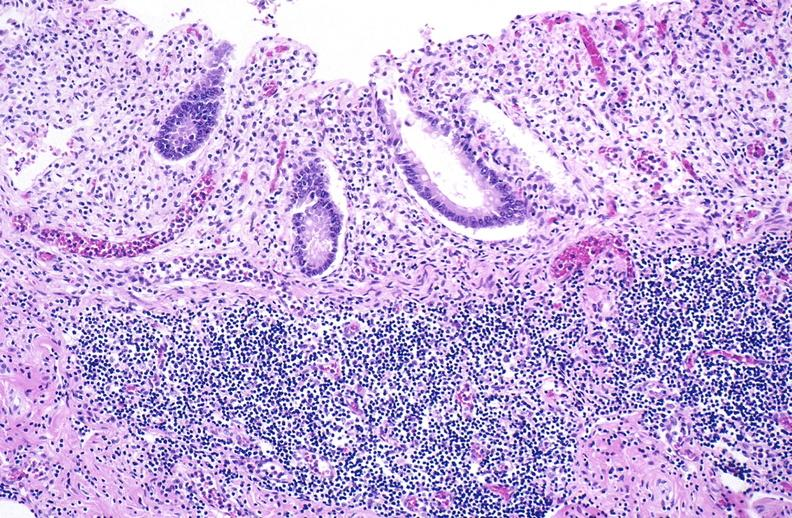s an opened peritoneal cavity cause by fibrous band strangulation present?
Answer the question using a single word or phrase. No 